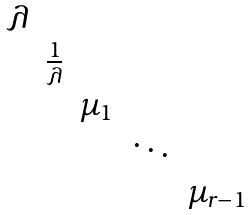<formula> <loc_0><loc_0><loc_500><loc_500>\begin{matrix} \lambda & & & & & \\ & \frac { 1 } { \lambda } & & & & \\ & & \mu _ { 1 } & & \\ & & & \ddots & \\ & & & & \mu _ { r - 1 } \end{matrix}</formula> 